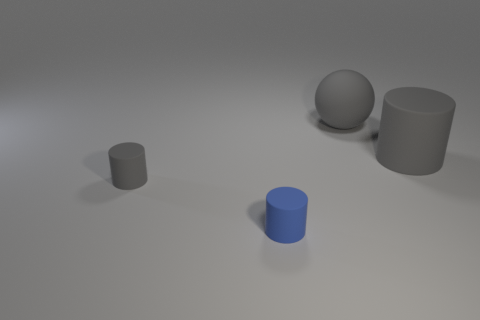There is a sphere that is the same material as the tiny gray object; what color is it?
Keep it short and to the point. Gray. How many gray spheres have the same material as the tiny blue object?
Your answer should be very brief. 1. Is the size of the rubber cylinder that is left of the blue matte thing the same as the gray cylinder that is right of the blue cylinder?
Keep it short and to the point. No. What material is the cylinder that is behind the gray cylinder to the left of the small blue rubber thing?
Your answer should be compact. Rubber. Are there fewer gray cylinders behind the tiny blue rubber cylinder than objects in front of the gray ball?
Offer a terse response. Yes. Is there anything else that has the same shape as the tiny blue thing?
Provide a short and direct response. Yes. There is a blue object; are there any big gray cylinders behind it?
Your response must be concise. Yes. There is a blue matte object; what shape is it?
Give a very brief answer. Cylinder. How many things are either small objects that are left of the blue matte thing or large yellow rubber objects?
Your answer should be compact. 1. How many other things are the same color as the ball?
Your answer should be very brief. 2. 